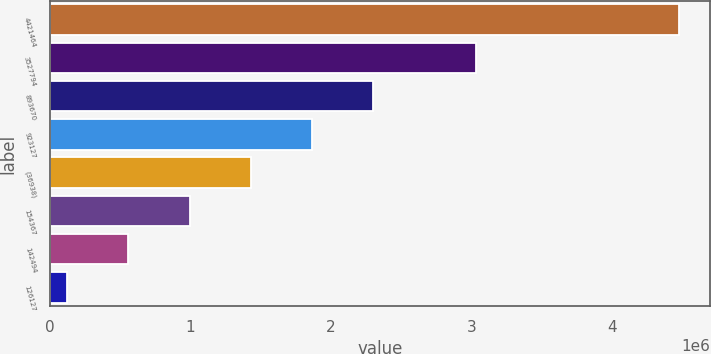<chart> <loc_0><loc_0><loc_500><loc_500><bar_chart><fcel>4421464<fcel>3527794<fcel>893670<fcel>923127<fcel>(36938)<fcel>154367<fcel>142494<fcel>126127<nl><fcel>4.47454e+06<fcel>3.03363e+06<fcel>2.30033e+06<fcel>1.86549e+06<fcel>1.43065e+06<fcel>995809<fcel>560968<fcel>126127<nl></chart> 